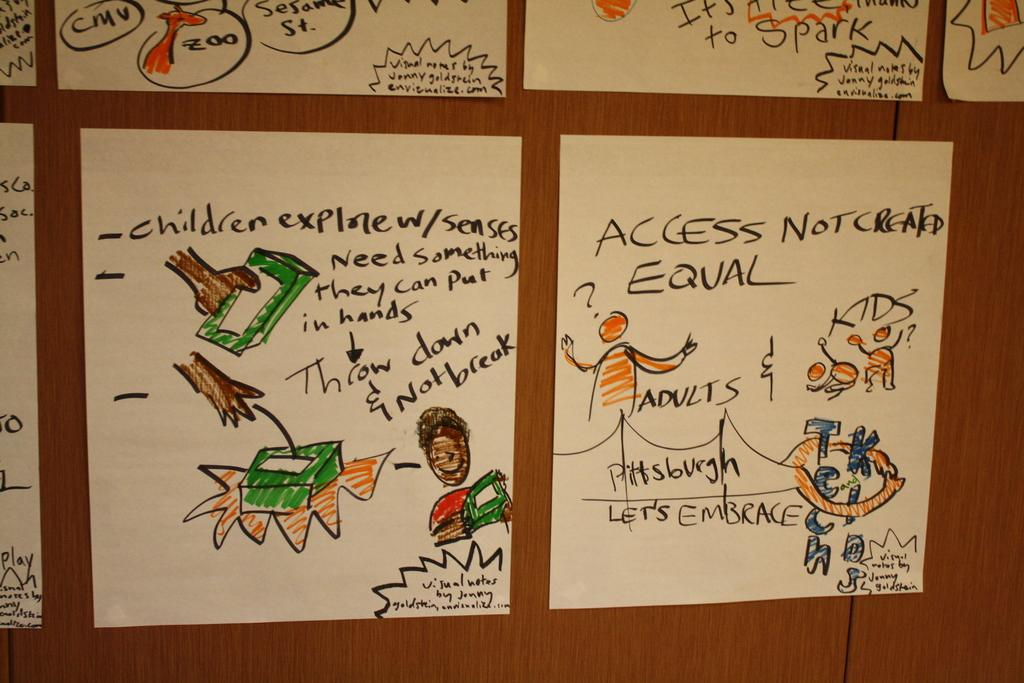What is present on the walls in the image? There are posters in the image. What can be seen on the posters? The posters have text and drawings on them. What material is the posters attached to? The posters are pasted on a wooden board. What is the color of the background in the image? The background color is brown. How many stockings are hanging from the wooden board in the image? There are no stockings present in the image; it only features posters on a wooden board. Can you tell me how many bikes are parked next to the wooden board in the image? There are no bikes present in the image; it only features posters on a wooden board. 